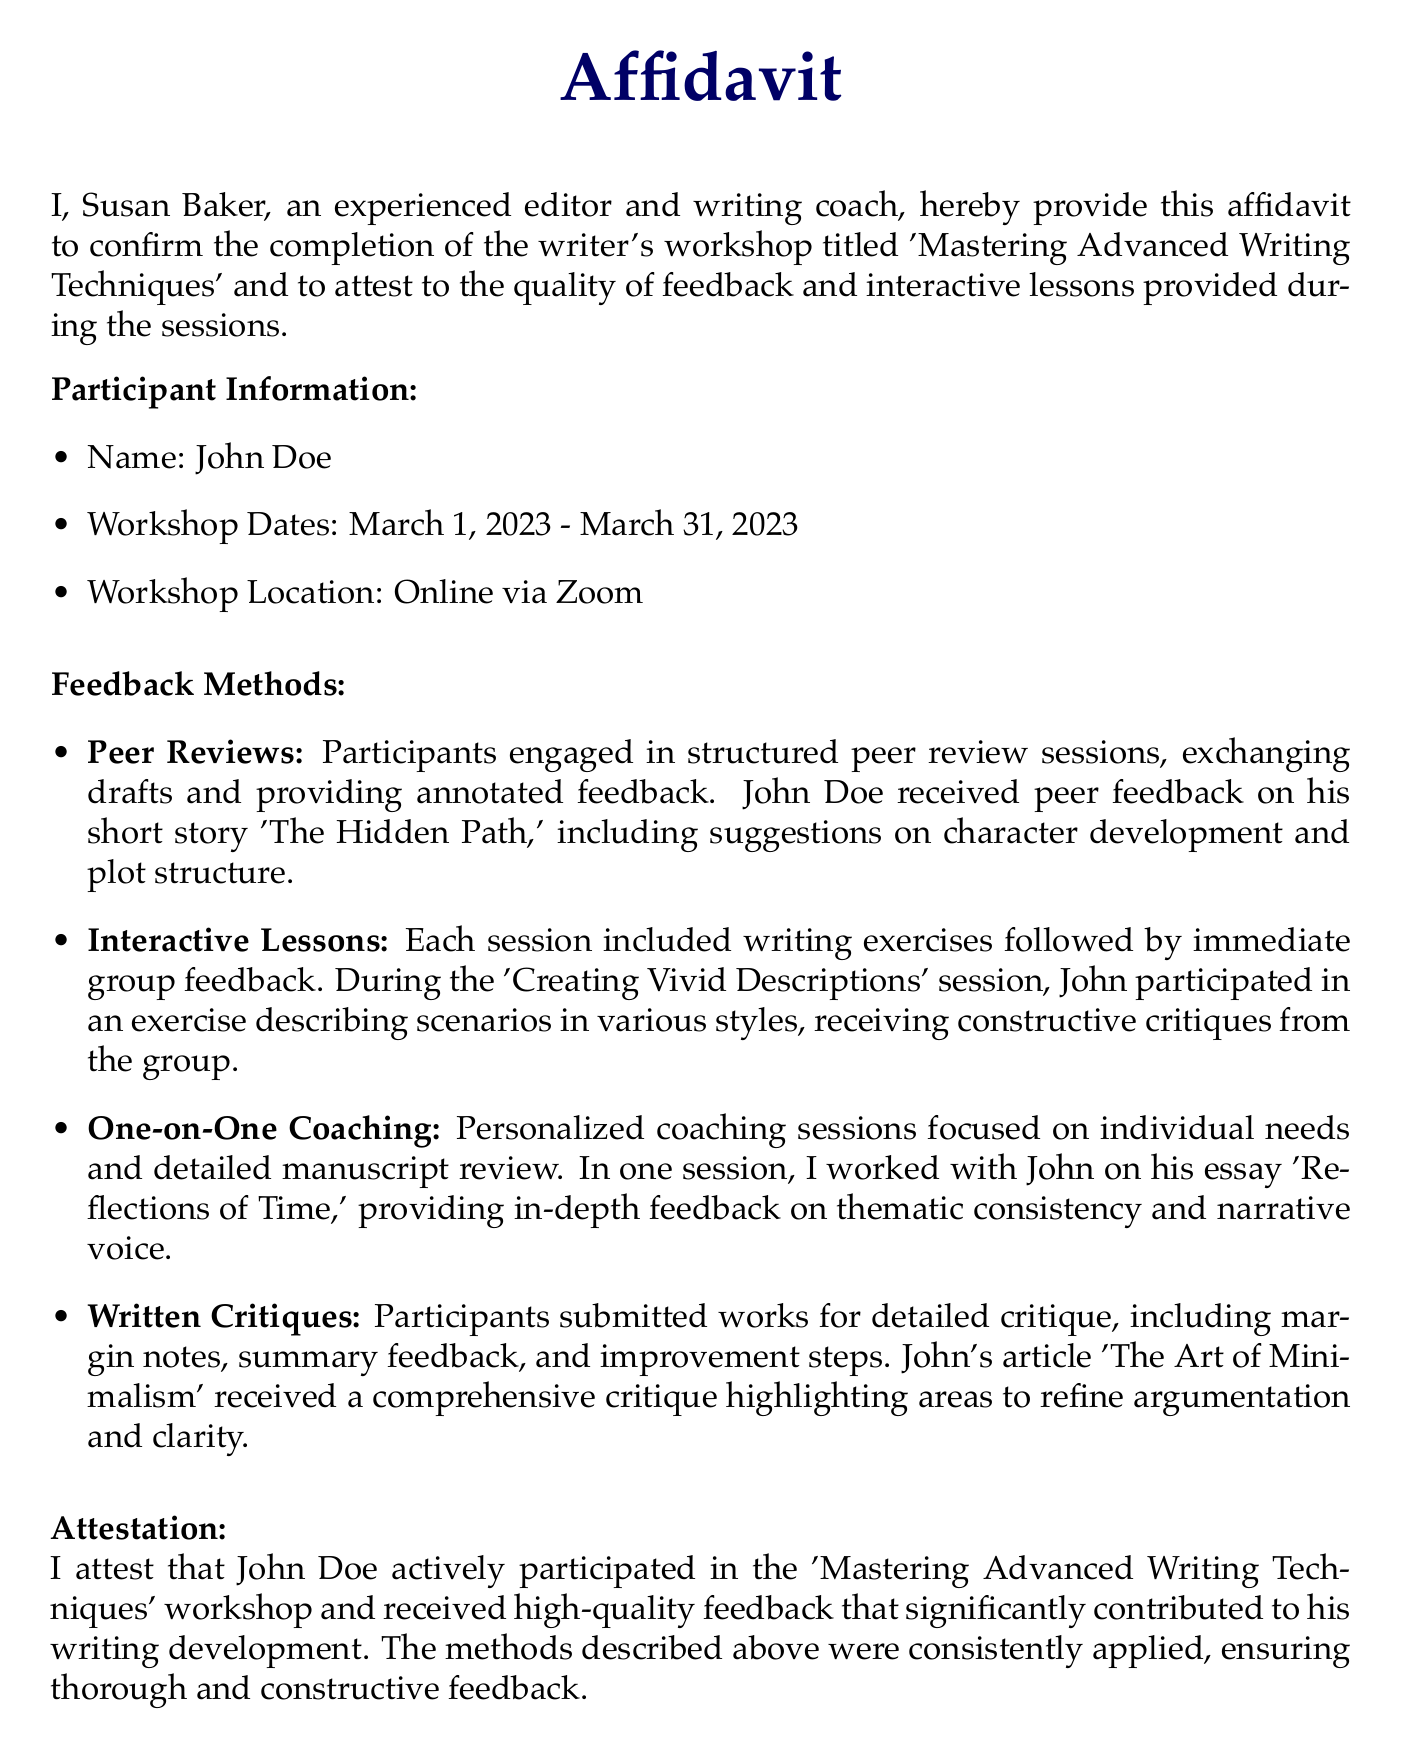What is the name of the participant? The name of the participant is stated in the participant information section of the document.
Answer: John Doe What is the workshop title? The workshop title is provided in the opening of the affidavit.
Answer: Mastering Advanced Writing Techniques When did the workshop take place? The workshop dates are mentioned in the participant information section.
Answer: March 1, 2023 - March 31, 2023 What method involved exchanging drafts? The method that involved exchanging drafts is specified in the feedback methods section.
Answer: Peer Reviews Which session focused on vivid descriptions? The session focusing on vivid descriptions is noted in the feedback methods section.
Answer: Creating Vivid Descriptions What type of feedback did John Doe receive on his article? The type of feedback received on John's article is detailed in the feedback methods section.
Answer: Comprehensive critique Who is the author of the affidavit? The author of the affidavit is mentioned at the bottom of the document.
Answer: Susan Baker What date was the affidavit signed? The date of the affidavit is found in the signing section of the document.
Answer: April 5, 2023 What was one specific feedback focus discussed with John? One specific feedback focus discussed with John is provided in the feedback methods section.
Answer: Thematic consistency 